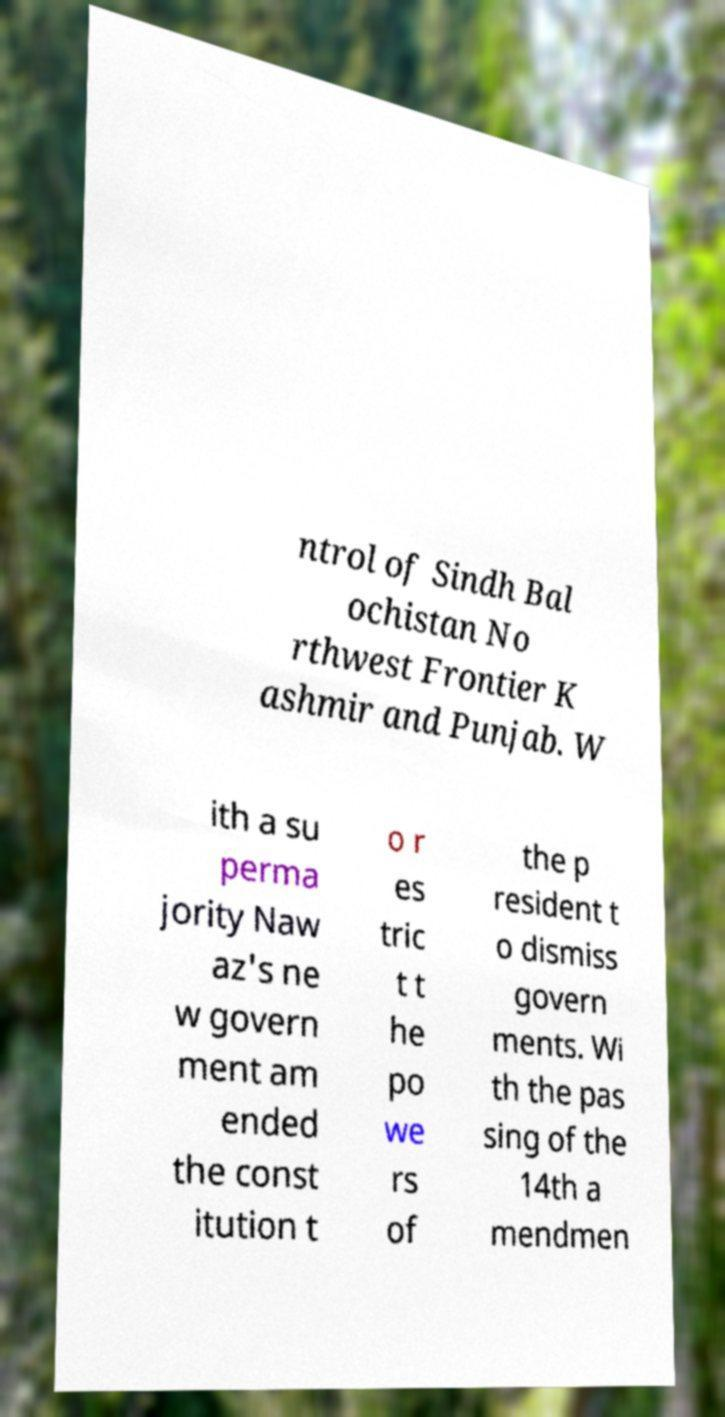Please identify and transcribe the text found in this image. ntrol of Sindh Bal ochistan No rthwest Frontier K ashmir and Punjab. W ith a su perma jority Naw az's ne w govern ment am ended the const itution t o r es tric t t he po we rs of the p resident t o dismiss govern ments. Wi th the pas sing of the 14th a mendmen 